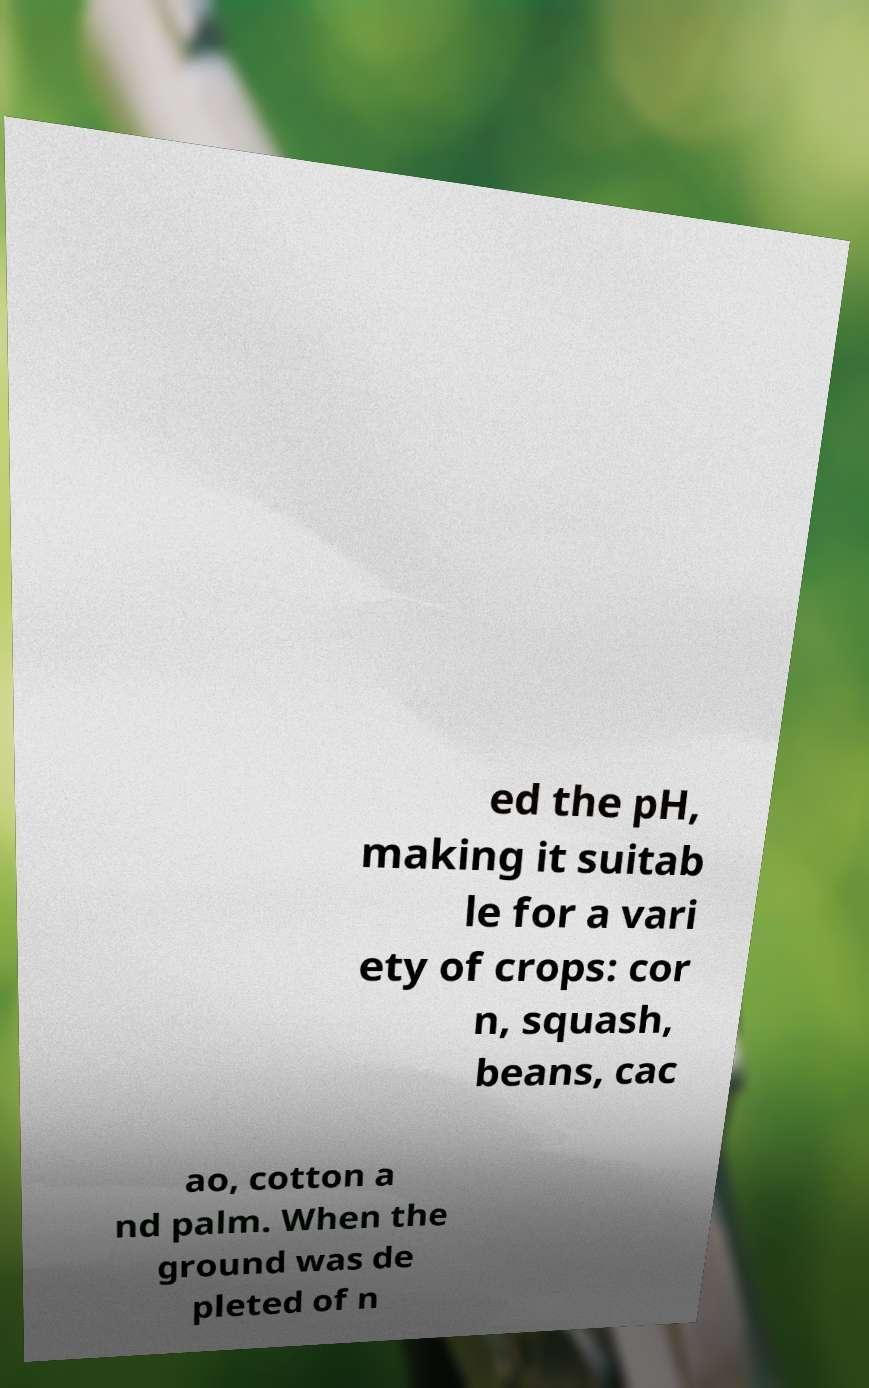Please identify and transcribe the text found in this image. ed the pH, making it suitab le for a vari ety of crops: cor n, squash, beans, cac ao, cotton a nd palm. When the ground was de pleted of n 